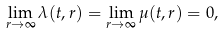Convert formula to latex. <formula><loc_0><loc_0><loc_500><loc_500>\lim _ { r \rightarrow \infty } \lambda ( t , r ) = \lim _ { r \rightarrow \infty } \mu ( t , r ) = 0 ,</formula> 